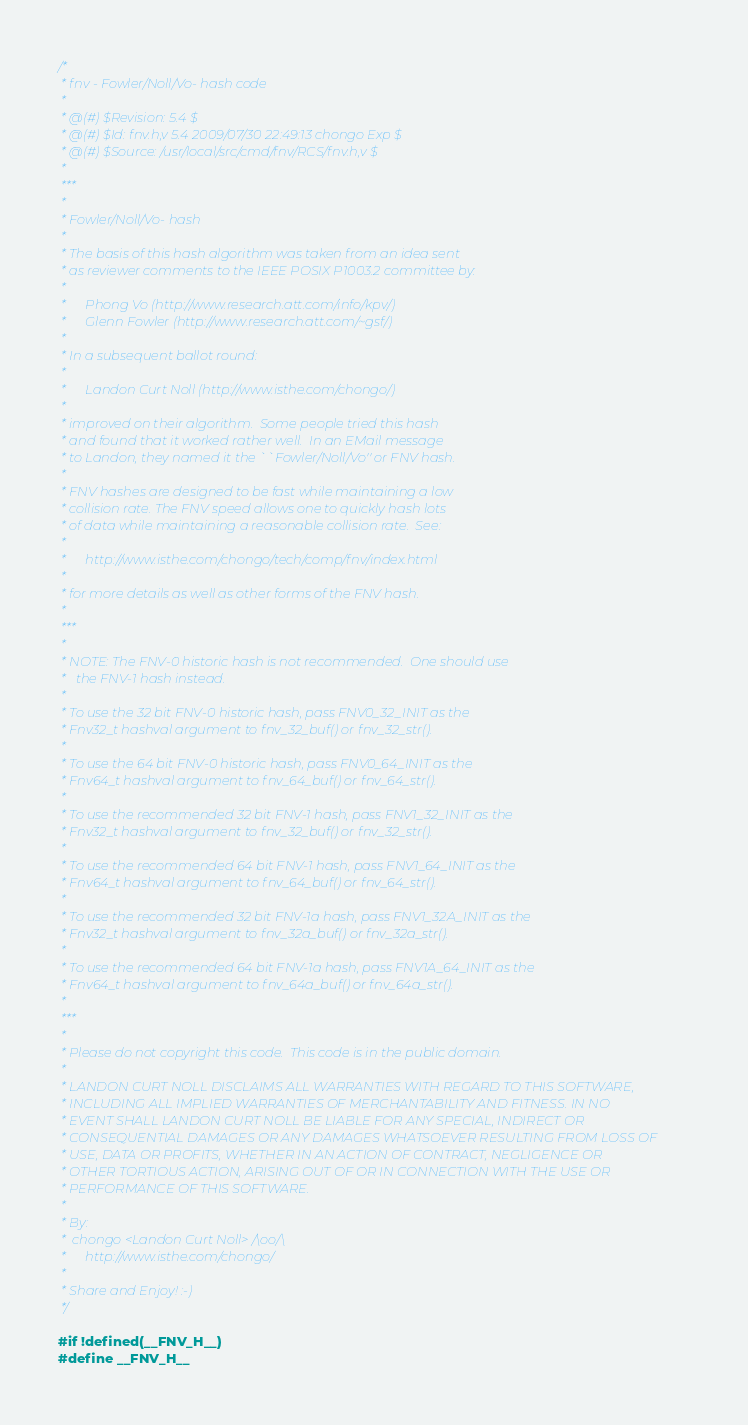Convert code to text. <code><loc_0><loc_0><loc_500><loc_500><_C_>/*
 * fnv - Fowler/Noll/Vo- hash code
 *
 * @(#) $Revision: 5.4 $
 * @(#) $Id: fnv.h,v 5.4 2009/07/30 22:49:13 chongo Exp $
 * @(#) $Source: /usr/local/src/cmd/fnv/RCS/fnv.h,v $
 *
 ***
 *
 * Fowler/Noll/Vo- hash
 *
 * The basis of this hash algorithm was taken from an idea sent
 * as reviewer comments to the IEEE POSIX P1003.2 committee by:
 *
 *      Phong Vo (http://www.research.att.com/info/kpv/)
 *      Glenn Fowler (http://www.research.att.com/~gsf/)
 *
 * In a subsequent ballot round:
 *
 *      Landon Curt Noll (http://www.isthe.com/chongo/)
 *
 * improved on their algorithm.  Some people tried this hash
 * and found that it worked rather well.  In an EMail message
 * to Landon, they named it the ``Fowler/Noll/Vo'' or FNV hash.
 *
 * FNV hashes are designed to be fast while maintaining a low
 * collision rate. The FNV speed allows one to quickly hash lots
 * of data while maintaining a reasonable collision rate.  See:
 *
 *      http://www.isthe.com/chongo/tech/comp/fnv/index.html
 *
 * for more details as well as other forms of the FNV hash.
 *
 ***
 *
 * NOTE: The FNV-0 historic hash is not recommended.  One should use
 *	 the FNV-1 hash instead.
 *
 * To use the 32 bit FNV-0 historic hash, pass FNV0_32_INIT as the
 * Fnv32_t hashval argument to fnv_32_buf() or fnv_32_str().
 *
 * To use the 64 bit FNV-0 historic hash, pass FNV0_64_INIT as the
 * Fnv64_t hashval argument to fnv_64_buf() or fnv_64_str().
 *
 * To use the recommended 32 bit FNV-1 hash, pass FNV1_32_INIT as the
 * Fnv32_t hashval argument to fnv_32_buf() or fnv_32_str().
 *
 * To use the recommended 64 bit FNV-1 hash, pass FNV1_64_INIT as the
 * Fnv64_t hashval argument to fnv_64_buf() or fnv_64_str().
 *
 * To use the recommended 32 bit FNV-1a hash, pass FNV1_32A_INIT as the
 * Fnv32_t hashval argument to fnv_32a_buf() or fnv_32a_str().
 *
 * To use the recommended 64 bit FNV-1a hash, pass FNV1A_64_INIT as the
 * Fnv64_t hashval argument to fnv_64a_buf() or fnv_64a_str().
 *
 ***
 *
 * Please do not copyright this code.  This code is in the public domain.
 *
 * LANDON CURT NOLL DISCLAIMS ALL WARRANTIES WITH REGARD TO THIS SOFTWARE,
 * INCLUDING ALL IMPLIED WARRANTIES OF MERCHANTABILITY AND FITNESS. IN NO
 * EVENT SHALL LANDON CURT NOLL BE LIABLE FOR ANY SPECIAL, INDIRECT OR
 * CONSEQUENTIAL DAMAGES OR ANY DAMAGES WHATSOEVER RESULTING FROM LOSS OF
 * USE, DATA OR PROFITS, WHETHER IN AN ACTION OF CONTRACT, NEGLIGENCE OR
 * OTHER TORTIOUS ACTION, ARISING OUT OF OR IN CONNECTION WITH THE USE OR
 * PERFORMANCE OF THIS SOFTWARE.
 *
 * By:
 *	chongo <Landon Curt Noll> /\oo/\
 *      http://www.isthe.com/chongo/
 *
 * Share and Enjoy!	:-)
 */

#if !defined(__FNV_H__)
#define __FNV_H__
</code> 